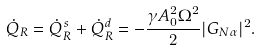<formula> <loc_0><loc_0><loc_500><loc_500>\dot { Q } _ { R } = \dot { Q } ^ { s } _ { R } + \dot { Q } ^ { d } _ { R } = - \frac { \gamma A _ { 0 } ^ { 2 } \Omega ^ { 2 } } { 2 } | G _ { N \alpha } | ^ { 2 } .</formula> 